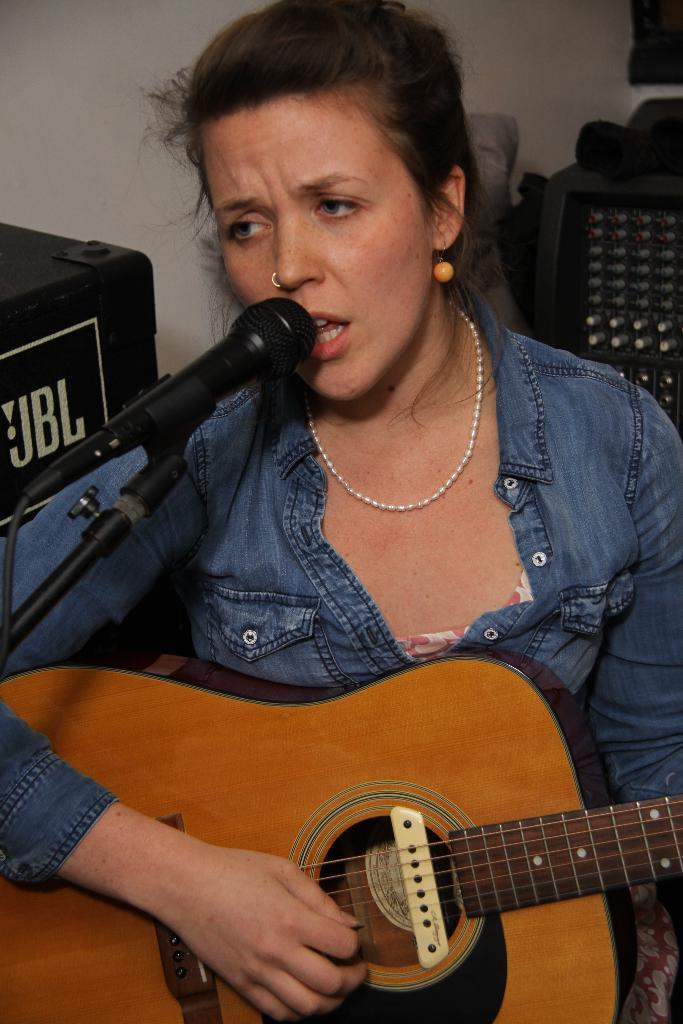Who is the main subject in the image? There is a woman in the image. What is the woman holding in the image? The woman is holding a guitar. What is the woman doing with the microphone in the image? The woman is singing on a microphone. What type of branch can be seen in the woman's hair in the image? There is no branch present in the woman's hair or in the image. 